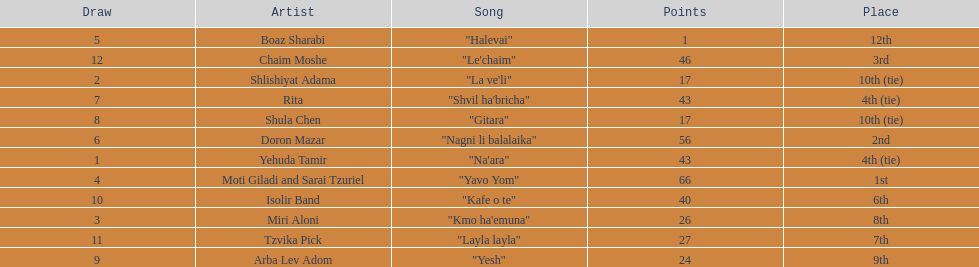What are the number of times an artist earned first place? 1. 